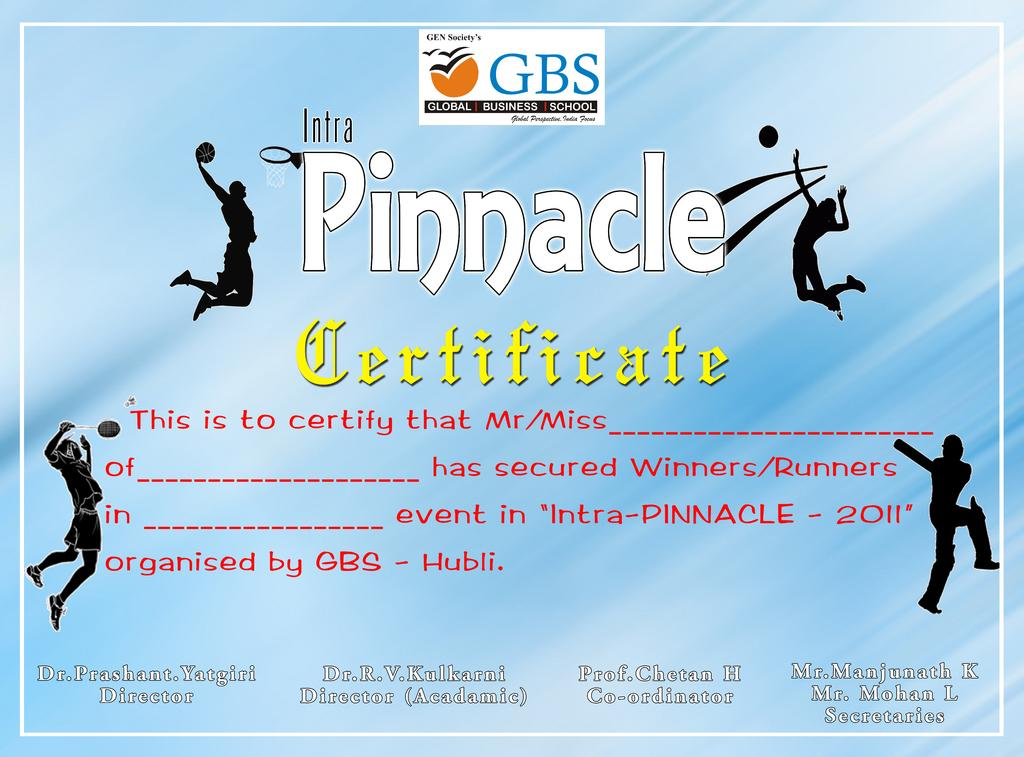<image>
Relay a brief, clear account of the picture shown. Certificate for Pinnacle has people playing sports on it. 